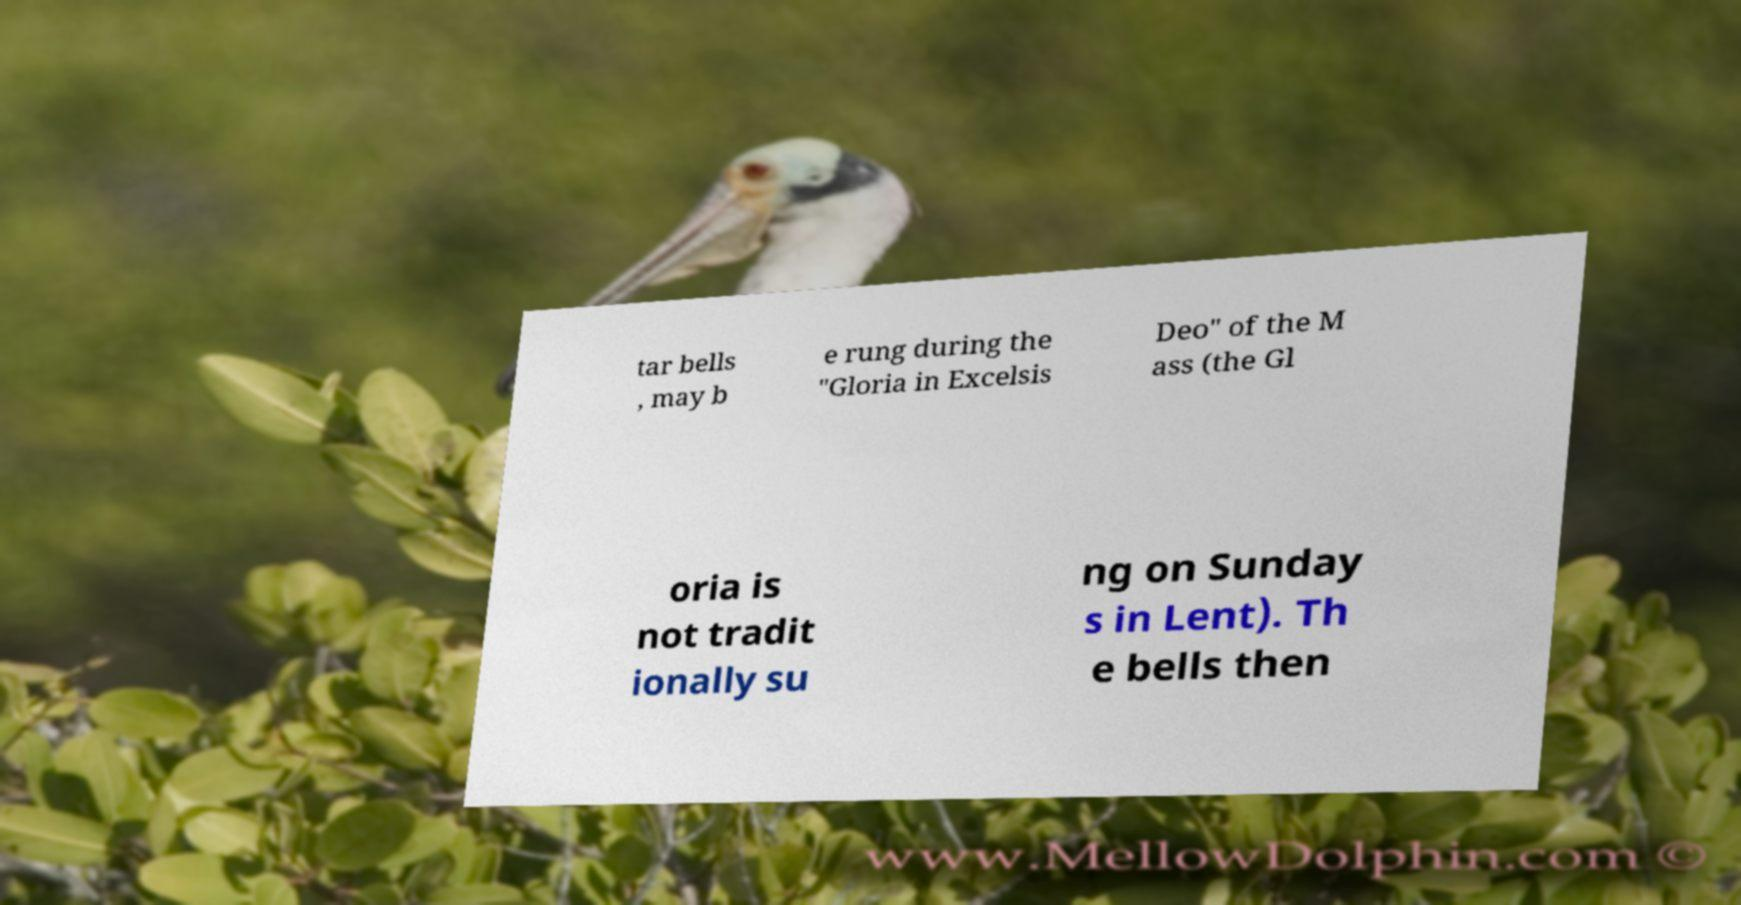Please read and relay the text visible in this image. What does it say? tar bells , may b e rung during the "Gloria in Excelsis Deo" of the M ass (the Gl oria is not tradit ionally su ng on Sunday s in Lent). Th e bells then 